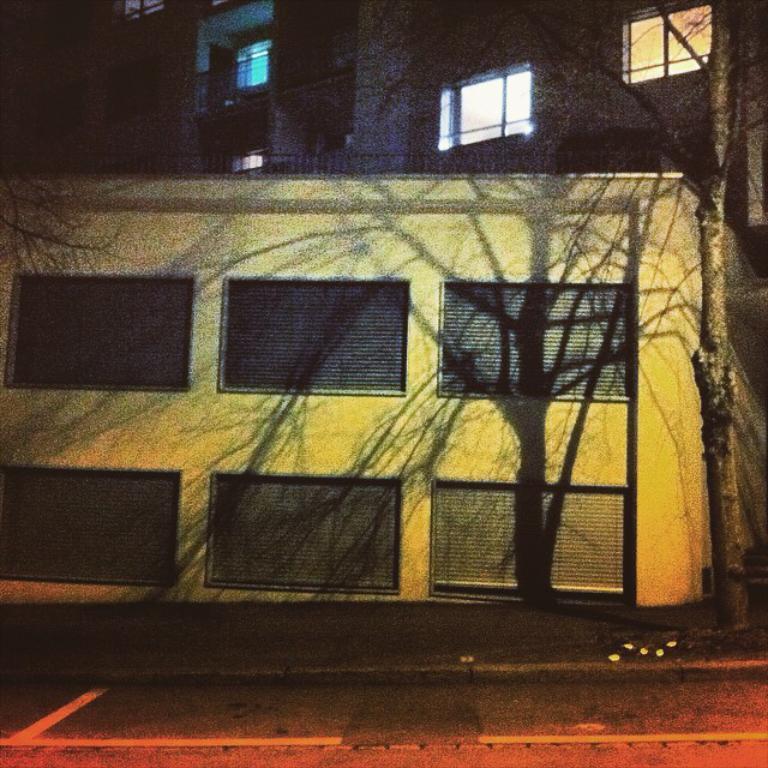Could you give a brief overview of what you see in this image? In this image I can see buildings, trees, windows and so on. This image is taken may be during night. 